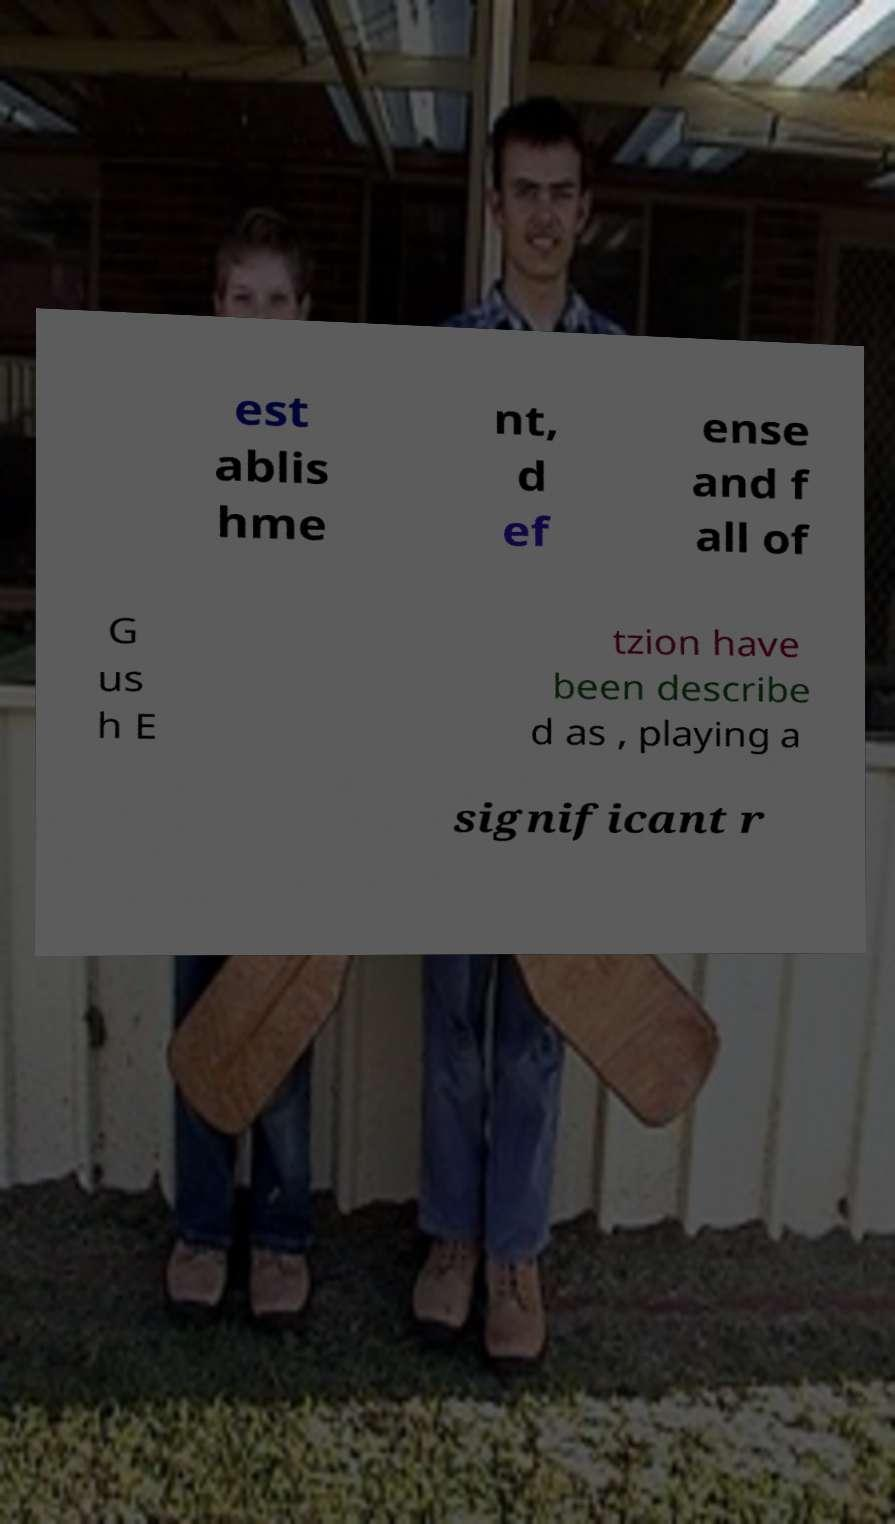Could you extract and type out the text from this image? est ablis hme nt, d ef ense and f all of G us h E tzion have been describe d as , playing a significant r 